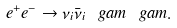Convert formula to latex. <formula><loc_0><loc_0><loc_500><loc_500>e ^ { + } e ^ { - } \to \nu _ { i } \bar { \nu } _ { i } \ g a m \ g a m .</formula> 